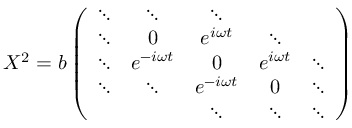<formula> <loc_0><loc_0><loc_500><loc_500>X ^ { 2 } = b \left ( \begin{array} { c c c c c } { \ddots } & { \ddots } & { \ddots } \\ { \ddots } & { 0 } & { { e ^ { i \omega t } } } & { \ddots } \\ { \ddots } & { { e ^ { - i \omega t } } } & { 0 } & { { e ^ { i \omega t } } } & { \ddots } \\ { \ddots } & { \ddots } & { { e ^ { - i \omega t } } } & { 0 } & { \ddots } & { \ddots } & { \ddots } & { \ddots } \end{array} \right )</formula> 